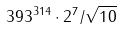<formula> <loc_0><loc_0><loc_500><loc_500>3 9 3 ^ { 3 1 4 } \cdot 2 ^ { 7 } / \sqrt { 1 0 }</formula> 